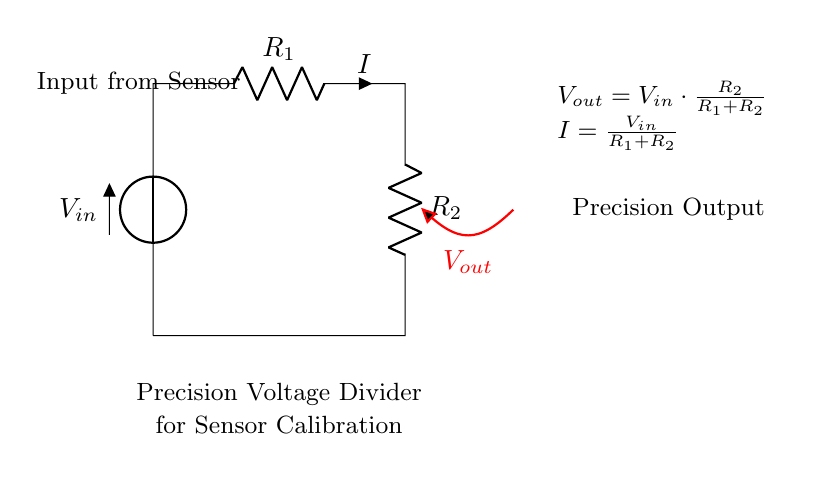What is the input voltage from the sensor? The input voltage, labeled as V_in, is the voltage provided by the sensor, but its value is not specified in the diagram. It represents the voltage supply for the voltage divider circuit.
Answer: V_in What are the resistance values in the circuit? The circuit shows two resistors, R_1 and R_2, but their exact values are not provided in the diagram. They are critical for determining the output voltage of the divider.
Answer: R_1 and R_2 What is the output voltage formula? The output voltage formula is provided in the diagram as V_out = V_in * (R_2 / (R_1 + R_2)). This indicates how V_out is derived based on the input voltage and the resistances in the circuit.
Answer: V_out = V_in * (R_2 / (R_1 + R_2)) What is the relationship between input and output voltage? The relationship indicates that the output voltage is a fraction of the input voltage, specifically determined by the ratio of the resistances R_2 and R_1 + R_2. This illustrates the voltage division principle in action.
Answer: V_out is a fraction of V_in What is the total current flowing in the circuit? The total current is defined by the formula I = V_in / (R_1 + R_2). This shows how the input voltage and the combined resistance of R_1 and R_2 determine the current in the circuit.
Answer: I = V_in / (R_1 + R_2) How does changing R_2 affect V_out? Changing R_2 changes the ratio of R_2 to (R_1 + R_2) in the output voltage formula. Increasing R_2 will increase V_out, while decreasing it will lower V_out. This illustrates how the output voltage is sensitive to changes in resistance.
Answer: Increases V_out 